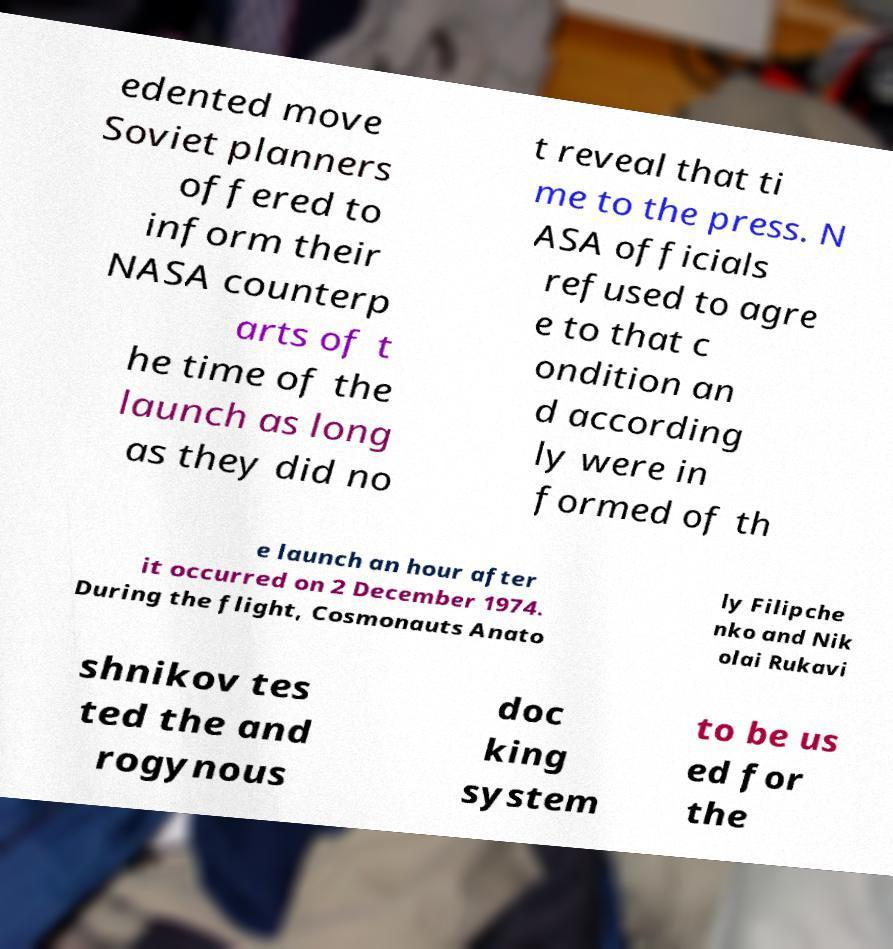Could you extract and type out the text from this image? edented move Soviet planners offered to inform their NASA counterp arts of t he time of the launch as long as they did no t reveal that ti me to the press. N ASA officials refused to agre e to that c ondition an d according ly were in formed of th e launch an hour after it occurred on 2 December 1974. During the flight, Cosmonauts Anato ly Filipche nko and Nik olai Rukavi shnikov tes ted the and rogynous doc king system to be us ed for the 